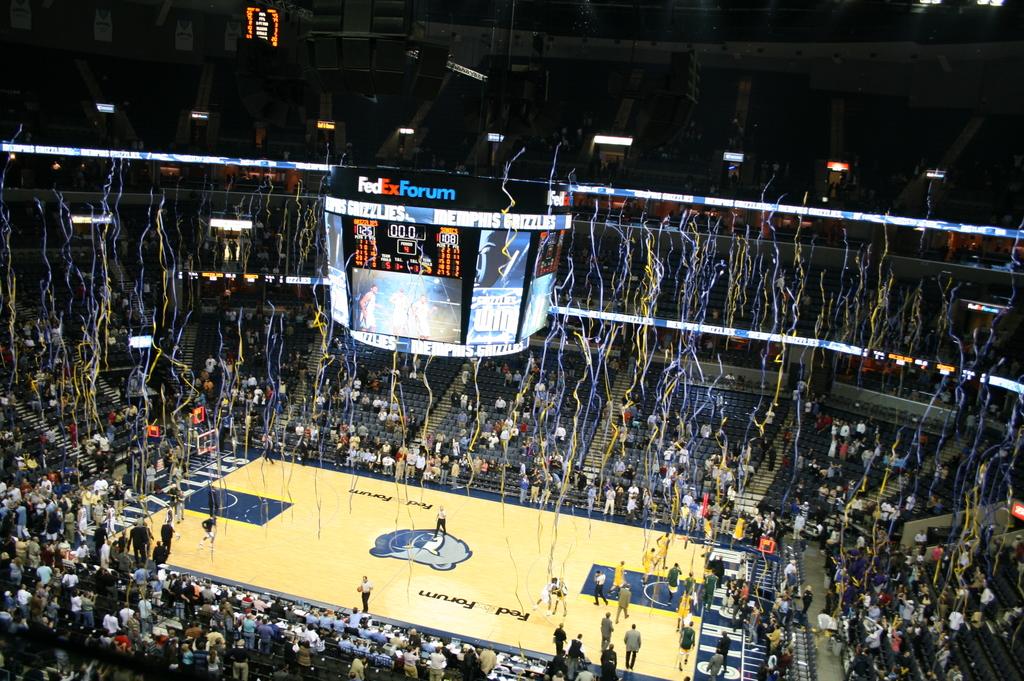What does it say above the screen?
Give a very brief answer. Fedex forum. How many minutes are left on the clock?
Provide a succinct answer. 0. 